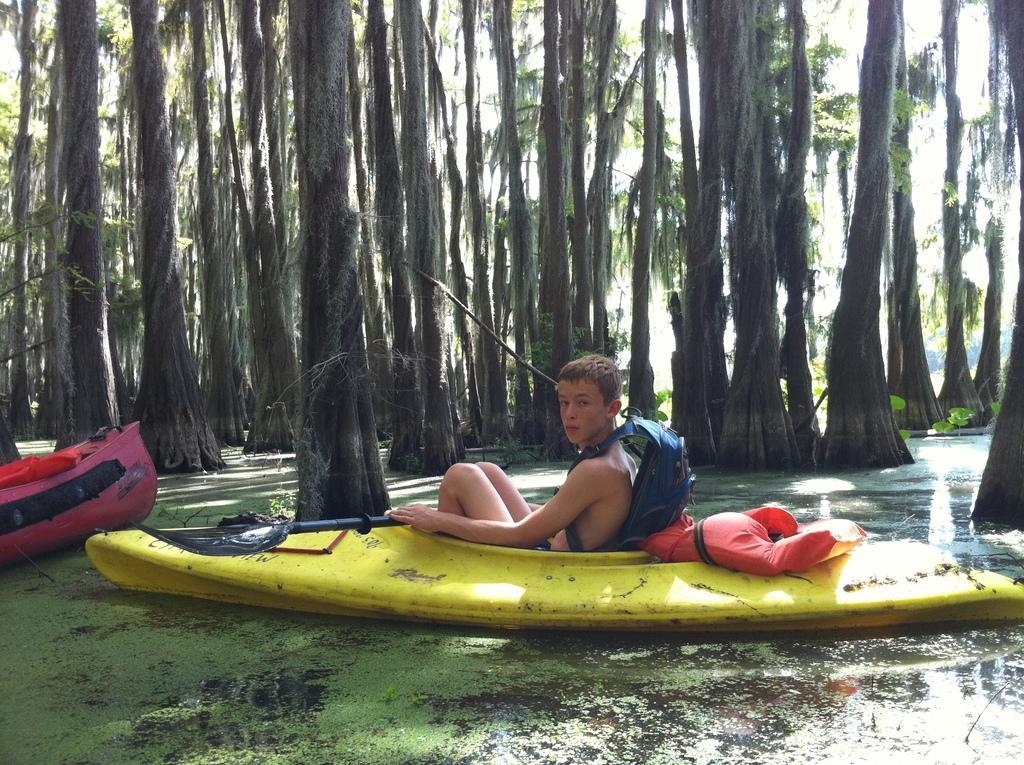Describe this image in one or two sentences. In this picture I can see there is a boy sitting in the boat and he is wearing a bag and there is a life jacket. The water is dirty and there is another boat on top left side and there are trees in the backdrop. 